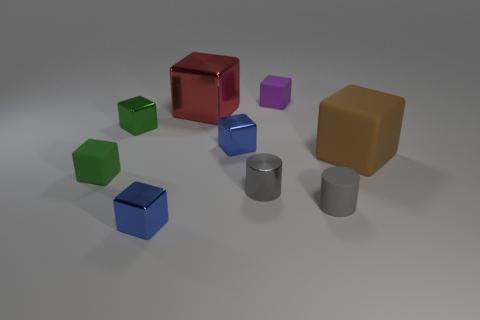There is a large metal block; is its color the same as the tiny metal block that is in front of the large brown block?
Your answer should be very brief. No. What number of other things are there of the same color as the metallic cylinder?
Make the answer very short. 1. Are there fewer brown matte blocks than big cyan spheres?
Keep it short and to the point. No. There is a blue cube that is on the right side of the large block that is left of the small purple cube; how many brown cubes are on the left side of it?
Your answer should be compact. 0. There is a green thing that is to the left of the green metal thing; how big is it?
Give a very brief answer. Small. Does the green thing that is in front of the green shiny block have the same shape as the brown matte object?
Provide a short and direct response. Yes. There is a brown object that is the same shape as the big red shiny thing; what is its material?
Keep it short and to the point. Rubber. Is there any other thing that has the same size as the brown matte block?
Your answer should be compact. Yes. Are there any green blocks?
Offer a very short reply. Yes. The block that is in front of the rubber cube that is on the left side of the small blue thing behind the big brown rubber object is made of what material?
Provide a succinct answer. Metal. 